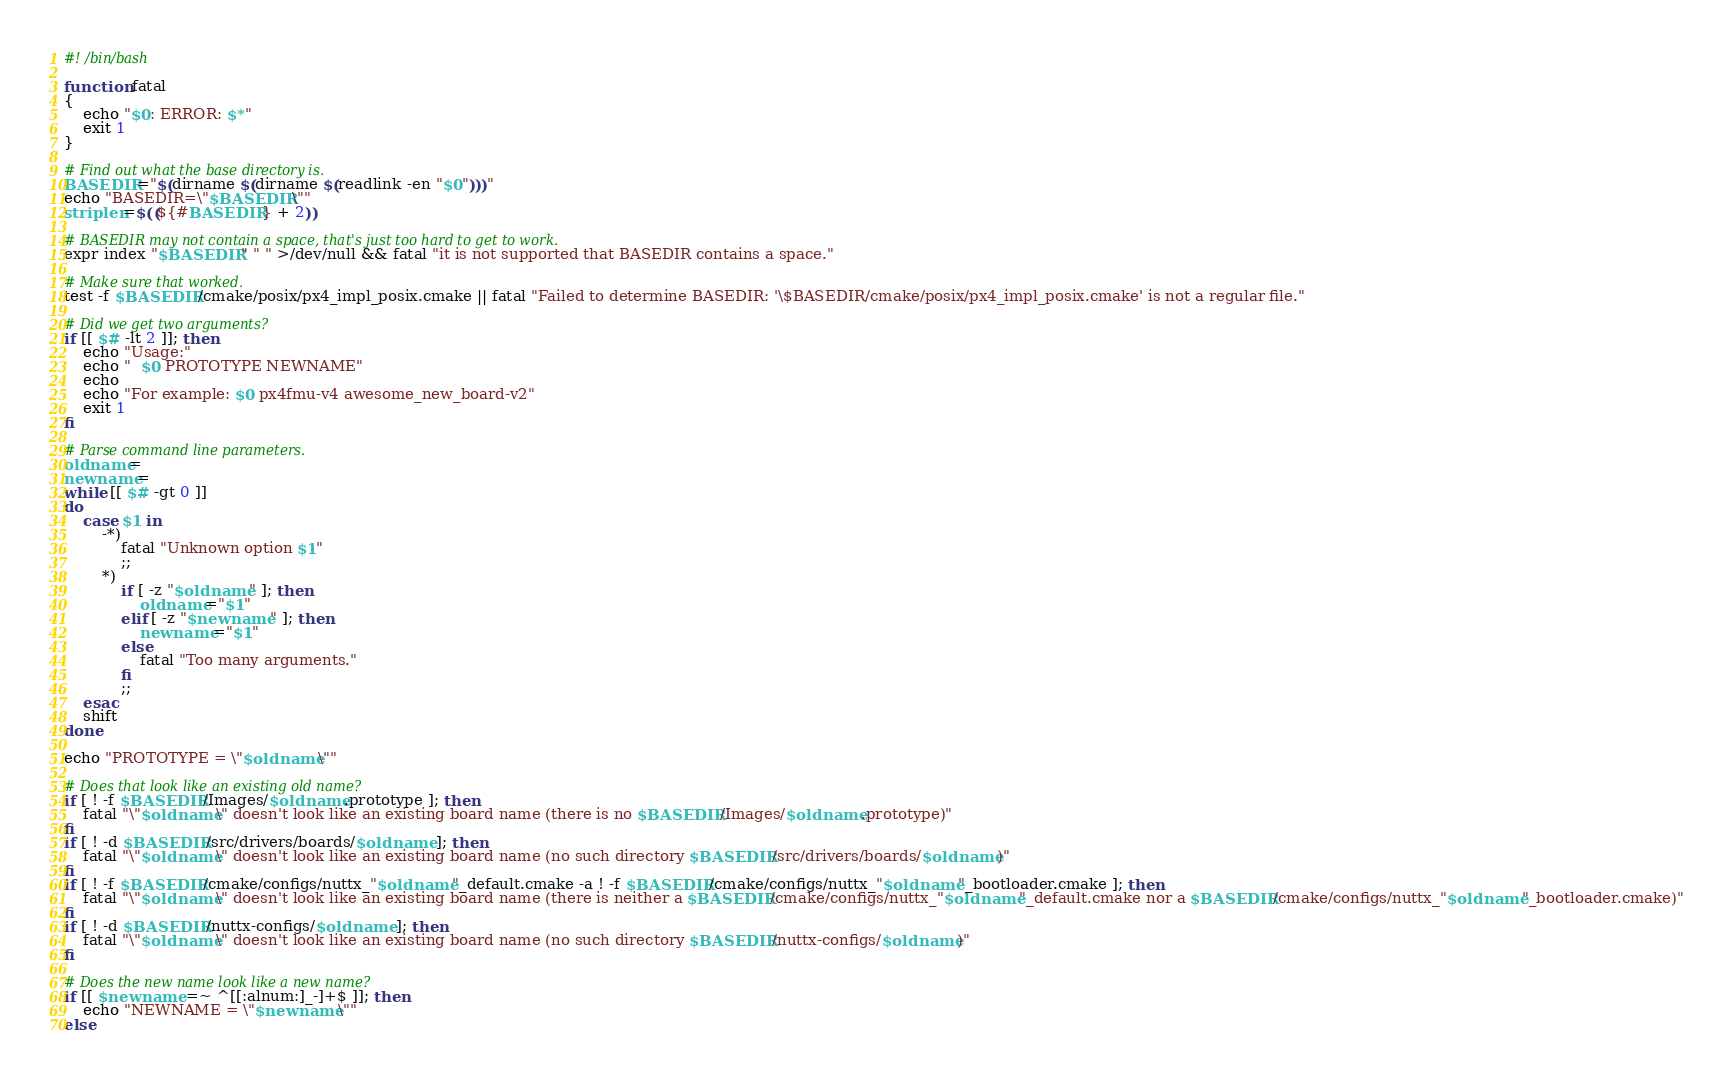<code> <loc_0><loc_0><loc_500><loc_500><_Bash_>#! /bin/bash

function fatal
{
	echo "$0: ERROR: $*"
	exit 1
}

# Find out what the base directory is.
BASEDIR="$(dirname $(dirname $(readlink -en "$0")))"
echo "BASEDIR=\"$BASEDIR\""
striplen=$((${#BASEDIR} + 2))

# BASEDIR may not contain a space, that's just too hard to get to work.
expr index "$BASEDIR" " " >/dev/null && fatal "it is not supported that BASEDIR contains a space."

# Make sure that worked.
test -f $BASEDIR/cmake/posix/px4_impl_posix.cmake || fatal "Failed to determine BASEDIR: '\$BASEDIR/cmake/posix/px4_impl_posix.cmake' is not a regular file."

# Did we get two arguments?
if [[ $# -lt 2 ]]; then
	echo "Usage:"
	echo "  $0 PROTOTYPE NEWNAME"
	echo
	echo "For example: $0 px4fmu-v4 awesome_new_board-v2"
	exit 1
fi

# Parse command line parameters.
oldname=
newname=
while [[ $# -gt 0 ]]
do
	case $1 in
		-*)
			fatal "Unknown option $1"
			;;
		*)
			if [ -z "$oldname" ]; then
				oldname="$1"
			elif [ -z "$newname" ]; then
				newname="$1"
			else
				fatal "Too many arguments."
			fi
			;;
	esac
	shift
done

echo "PROTOTYPE = \"$oldname\""

# Does that look like an existing old name?
if [ ! -f $BASEDIR/Images/$oldname.prototype ]; then
	fatal "\"$oldname\" doesn't look like an existing board name (there is no $BASEDIR/Images/$oldname.prototype)"
fi
if [ ! -d $BASEDIR/src/drivers/boards/$oldname ]; then
	fatal "\"$oldname\" doesn't look like an existing board name (no such directory $BASEDIR/src/drivers/boards/$oldname)"
fi
if [ ! -f $BASEDIR/cmake/configs/nuttx_"$oldname"_default.cmake -a ! -f $BASEDIR/cmake/configs/nuttx_"$oldname"_bootloader.cmake ]; then
	fatal "\"$oldname\" doesn't look like an existing board name (there is neither a $BASEDIR/cmake/configs/nuttx_"$oldname"_default.cmake nor a $BASEDIR/cmake/configs/nuttx_"$oldname"_bootloader.cmake)"
fi
if [ ! -d $BASEDIR/nuttx-configs/$oldname ]; then
	fatal "\"$oldname\" doesn't look like an existing board name (no such directory $BASEDIR/nuttx-configs/$oldname)"
fi

# Does the new name look like a new name?
if [[ $newname =~ ^[[:alnum:]_-]+$ ]]; then
	echo "NEWNAME = \"$newname\""
else</code> 